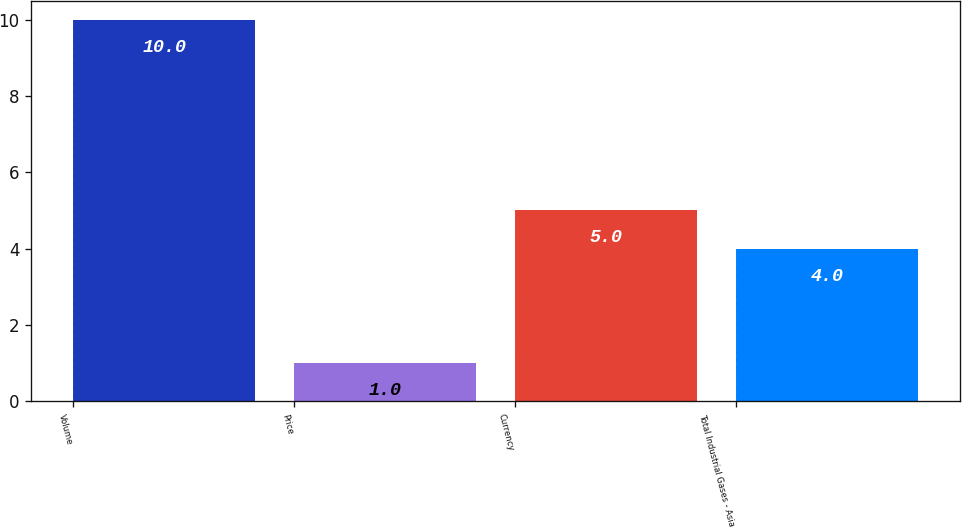Convert chart to OTSL. <chart><loc_0><loc_0><loc_500><loc_500><bar_chart><fcel>Volume<fcel>Price<fcel>Currency<fcel>Total Industrial Gases - Asia<nl><fcel>10<fcel>1<fcel>5<fcel>4<nl></chart> 